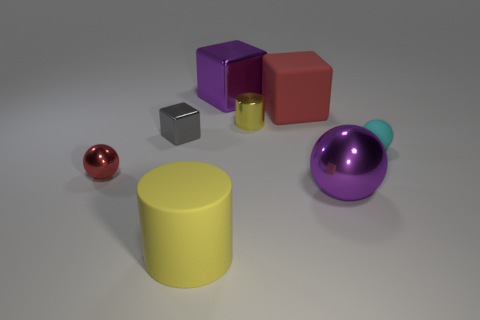Is the shape of the purple thing that is behind the tiny red shiny sphere the same as the purple shiny thing that is in front of the red sphere?
Keep it short and to the point. No. Is there any other thing that has the same shape as the small gray metallic object?
Provide a short and direct response. Yes. What is the shape of the tiny yellow thing that is the same material as the purple sphere?
Offer a terse response. Cylinder. Are there an equal number of tiny gray metal things that are behind the red cube and balls?
Keep it short and to the point. No. Is the material of the red object on the right side of the small gray cube the same as the purple thing that is behind the gray metallic thing?
Provide a short and direct response. No. There is a large purple metallic object in front of the red object that is behind the red metal object; what is its shape?
Your answer should be compact. Sphere. What color is the cylinder that is the same material as the cyan thing?
Keep it short and to the point. Yellow. Does the big cylinder have the same color as the big rubber block?
Your answer should be very brief. No. There is a yellow shiny object that is the same size as the cyan rubber object; what shape is it?
Offer a very short reply. Cylinder. What is the size of the gray shiny thing?
Your answer should be very brief. Small. 